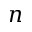Convert formula to latex. <formula><loc_0><loc_0><loc_500><loc_500>n</formula> 